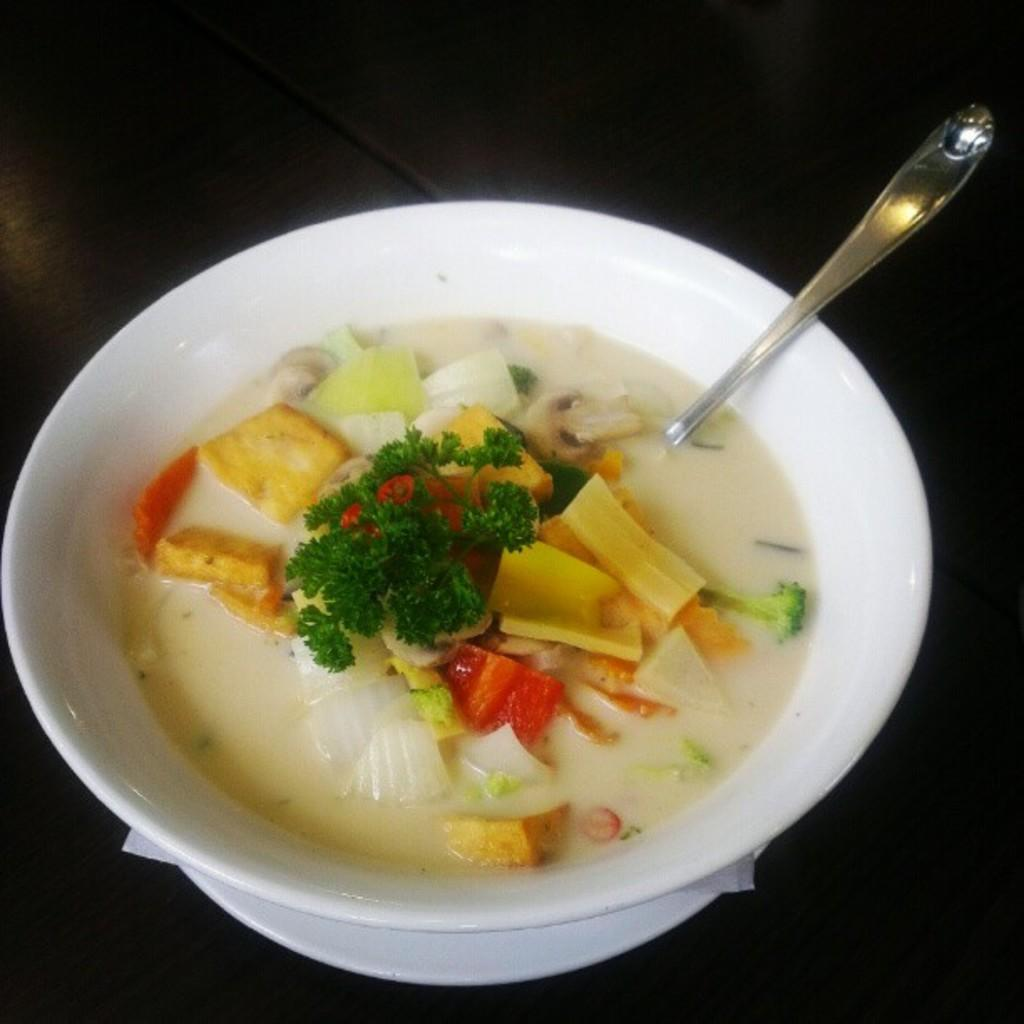What is the main object in the image? There is a bowl in the image. What is the color of the surface the bowl is on? The bowl is on a black surface. What is inside the bowl? There is a food item in the bowl. What utensil is present in the image? There is a spoon in the image. What type of engine can be seen powering the food item in the image? There is no engine present in the image, and the food item is not powered by any engine. 